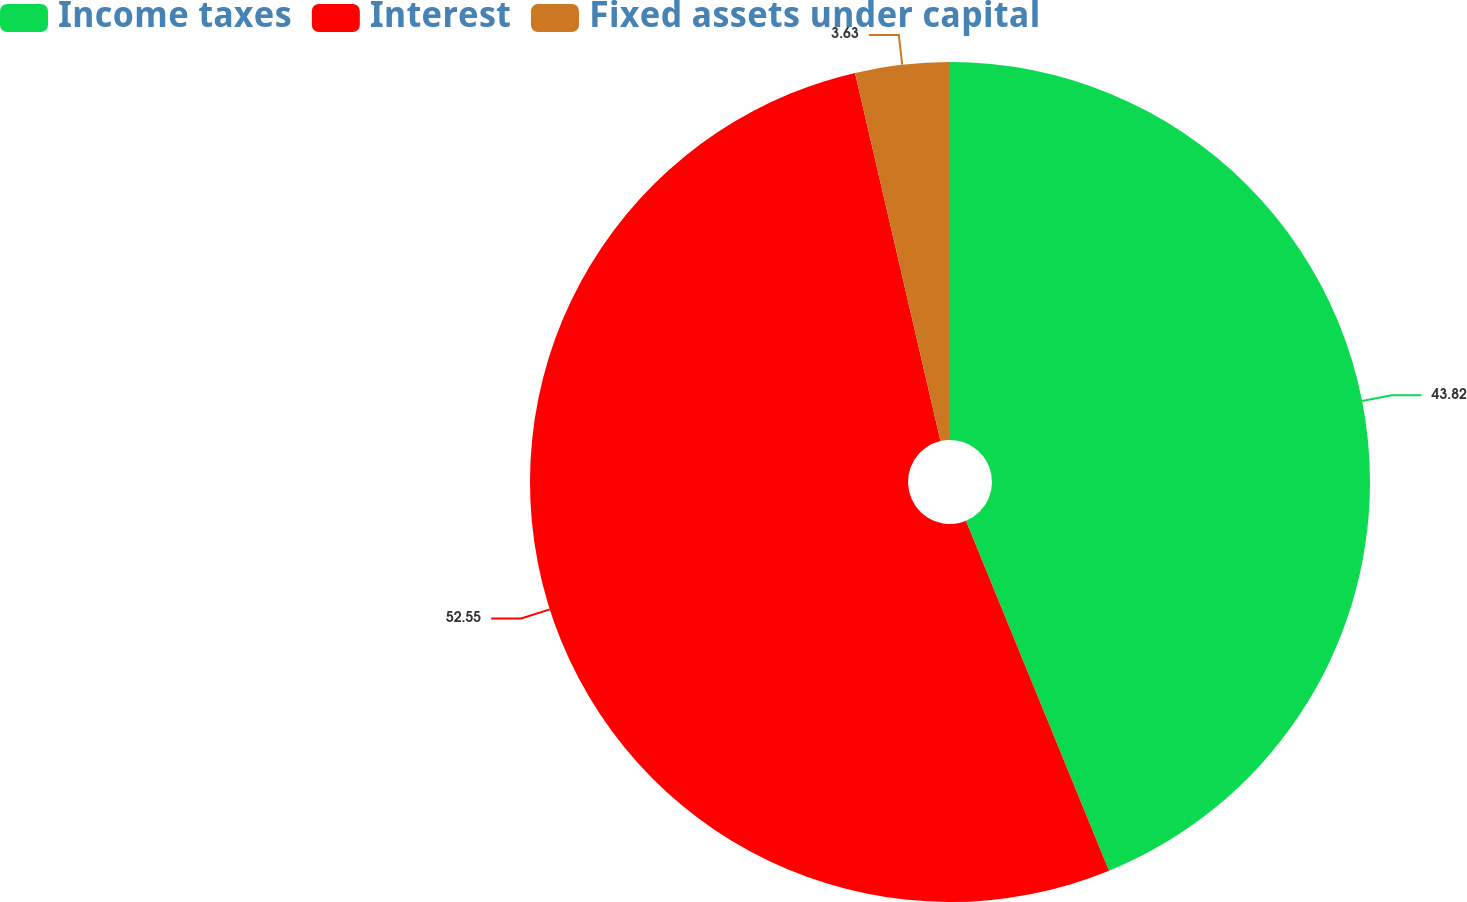Convert chart to OTSL. <chart><loc_0><loc_0><loc_500><loc_500><pie_chart><fcel>Income taxes<fcel>Interest<fcel>Fixed assets under capital<nl><fcel>43.82%<fcel>52.55%<fcel>3.63%<nl></chart> 